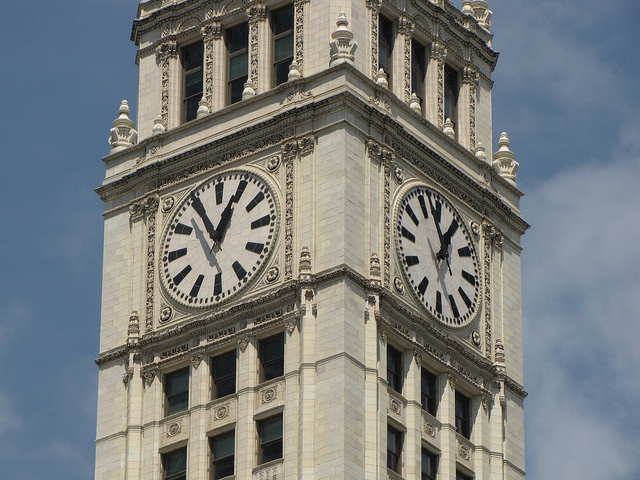Describe the objects in this image and their specific colors. I can see clock in gray, darkgray, and black tones and clock in gray, darkgray, and black tones in this image. 